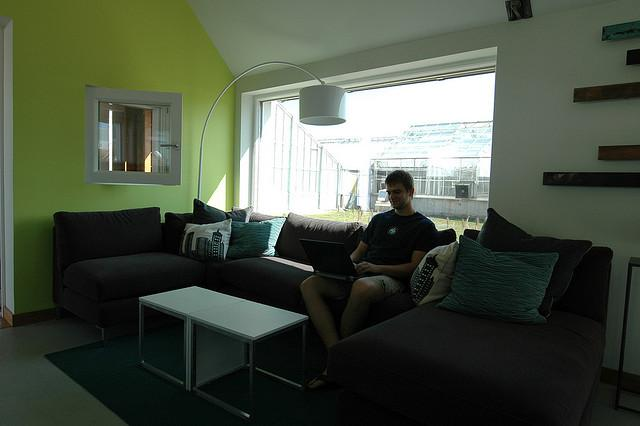What are his fingers touching? laptop 